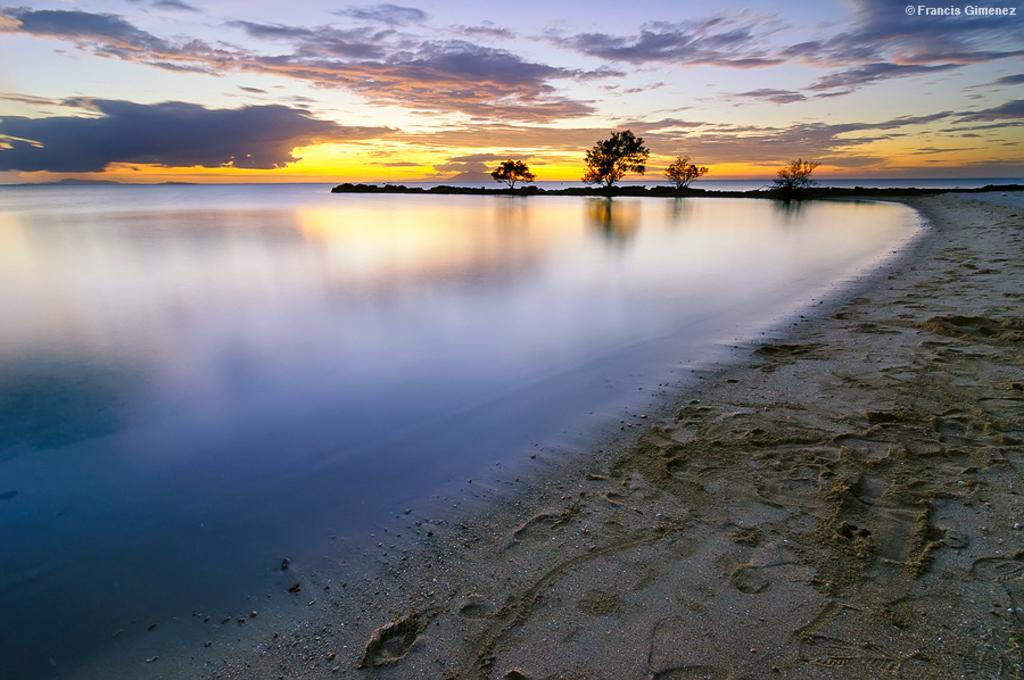What type of natural environment is depicted in the image? The image contains trees, sand, and water, which suggests a beach or coastal environment. What can be seen in the background of the image? The sky is visible in the background of the image. Is there any indication of a watermark in the image? Yes, there is a watermark in the top right corner of the image. What type of game is being played on the beach in the image? There is no game being played in the image; it only shows trees, sand, water, and the sky. How many birds can be seen flying over the water in the image? There are no birds visible in the image; it only shows trees, sand, water, and the sky. 